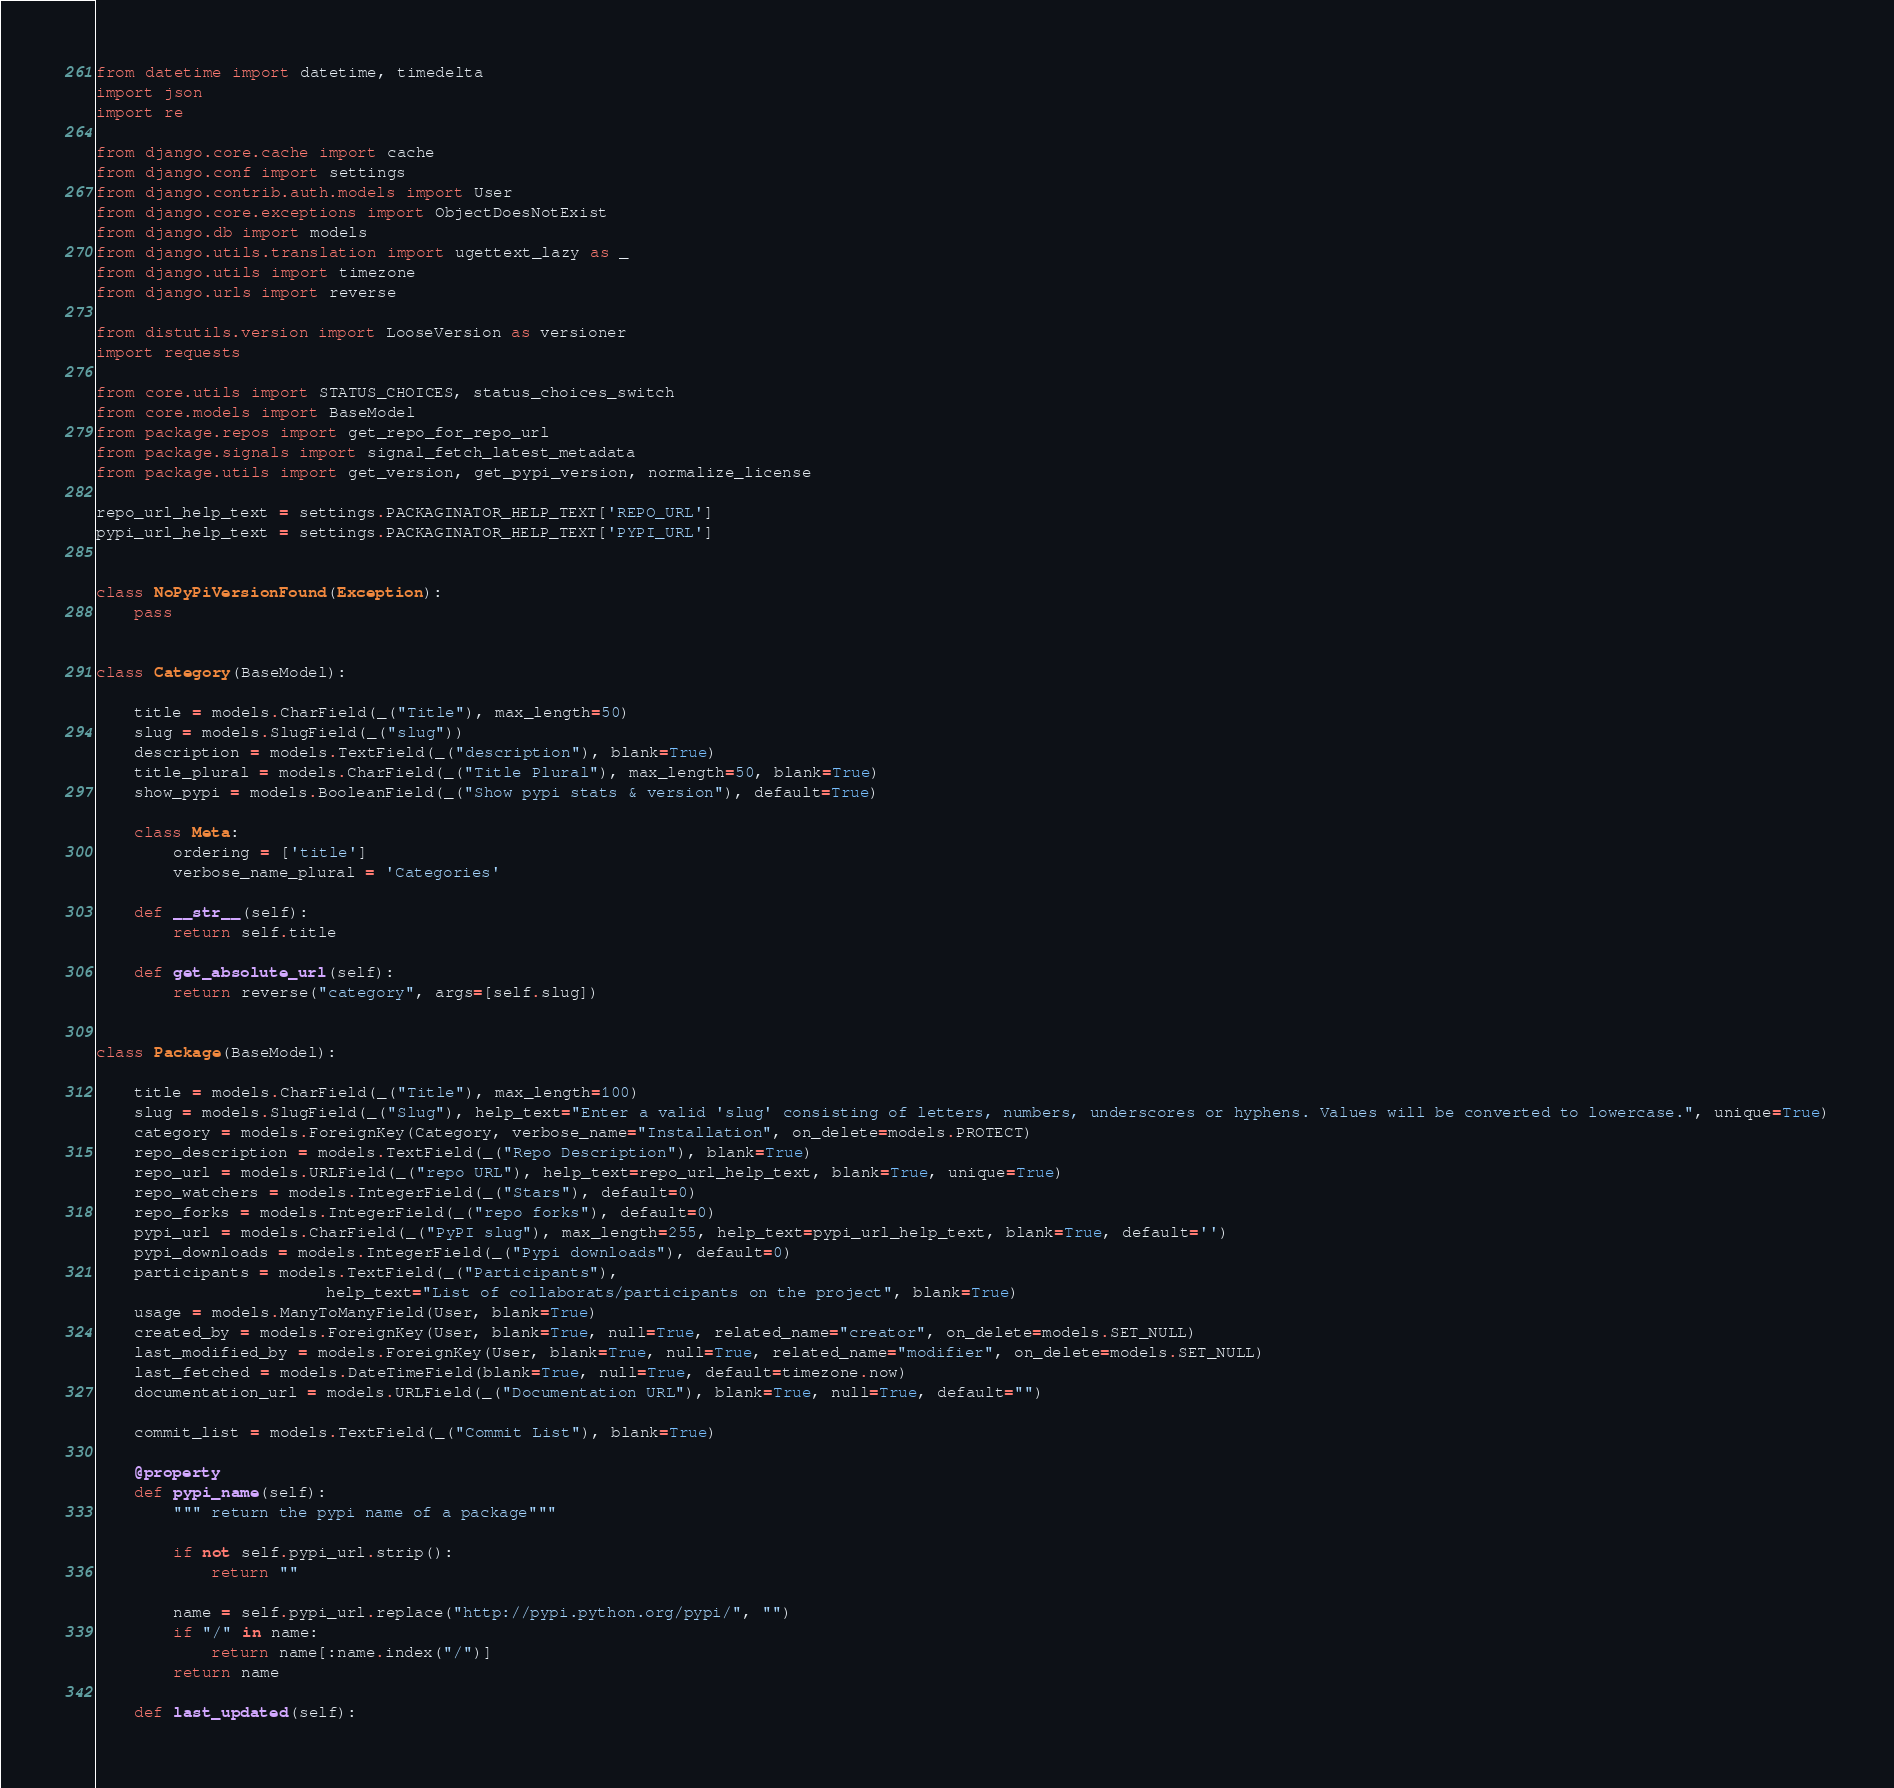<code> <loc_0><loc_0><loc_500><loc_500><_Python_>from datetime import datetime, timedelta
import json
import re

from django.core.cache import cache
from django.conf import settings
from django.contrib.auth.models import User
from django.core.exceptions import ObjectDoesNotExist
from django.db import models
from django.utils.translation import ugettext_lazy as _
from django.utils import timezone
from django.urls import reverse

from distutils.version import LooseVersion as versioner
import requests

from core.utils import STATUS_CHOICES, status_choices_switch
from core.models import BaseModel
from package.repos import get_repo_for_repo_url
from package.signals import signal_fetch_latest_metadata
from package.utils import get_version, get_pypi_version, normalize_license

repo_url_help_text = settings.PACKAGINATOR_HELP_TEXT['REPO_URL']
pypi_url_help_text = settings.PACKAGINATOR_HELP_TEXT['PYPI_URL']


class NoPyPiVersionFound(Exception):
    pass


class Category(BaseModel):

    title = models.CharField(_("Title"), max_length=50)
    slug = models.SlugField(_("slug"))
    description = models.TextField(_("description"), blank=True)
    title_plural = models.CharField(_("Title Plural"), max_length=50, blank=True)
    show_pypi = models.BooleanField(_("Show pypi stats & version"), default=True)

    class Meta:
        ordering = ['title']
        verbose_name_plural = 'Categories'

    def __str__(self):
        return self.title

    def get_absolute_url(self):
        return reverse("category", args=[self.slug])


class Package(BaseModel):

    title = models.CharField(_("Title"), max_length=100)
    slug = models.SlugField(_("Slug"), help_text="Enter a valid 'slug' consisting of letters, numbers, underscores or hyphens. Values will be converted to lowercase.", unique=True)
    category = models.ForeignKey(Category, verbose_name="Installation", on_delete=models.PROTECT)
    repo_description = models.TextField(_("Repo Description"), blank=True)
    repo_url = models.URLField(_("repo URL"), help_text=repo_url_help_text, blank=True, unique=True)
    repo_watchers = models.IntegerField(_("Stars"), default=0)
    repo_forks = models.IntegerField(_("repo forks"), default=0)
    pypi_url = models.CharField(_("PyPI slug"), max_length=255, help_text=pypi_url_help_text, blank=True, default='')
    pypi_downloads = models.IntegerField(_("Pypi downloads"), default=0)
    participants = models.TextField(_("Participants"),
                        help_text="List of collaborats/participants on the project", blank=True)
    usage = models.ManyToManyField(User, blank=True)
    created_by = models.ForeignKey(User, blank=True, null=True, related_name="creator", on_delete=models.SET_NULL)
    last_modified_by = models.ForeignKey(User, blank=True, null=True, related_name="modifier", on_delete=models.SET_NULL)
    last_fetched = models.DateTimeField(blank=True, null=True, default=timezone.now)
    documentation_url = models.URLField(_("Documentation URL"), blank=True, null=True, default="")

    commit_list = models.TextField(_("Commit List"), blank=True)

    @property
    def pypi_name(self):
        """ return the pypi name of a package"""

        if not self.pypi_url.strip():
            return ""

        name = self.pypi_url.replace("http://pypi.python.org/pypi/", "")
        if "/" in name:
            return name[:name.index("/")]
        return name

    def last_updated(self):</code> 